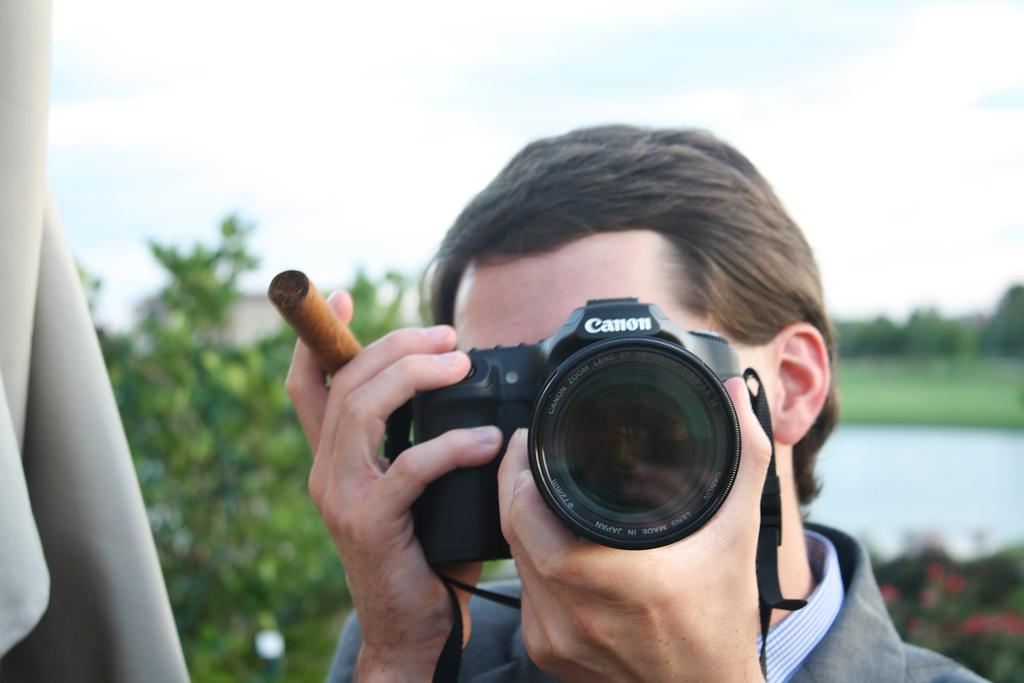What is the person in the image holding? The person is holding a camera and a cigar. What might the person be doing in the image? The person might be taking a photograph, given that they are holding a camera. What can be seen in the background of the image? There is a tree and the sky visible in the background of the image. What type of skin condition is visible on the person's face in the image? There is no indication of a skin condition visible on the person's face in the image. What error message is displayed on the camera in the image? There is no error message displayed on the camera in the image; it appears to be functioning normally. 